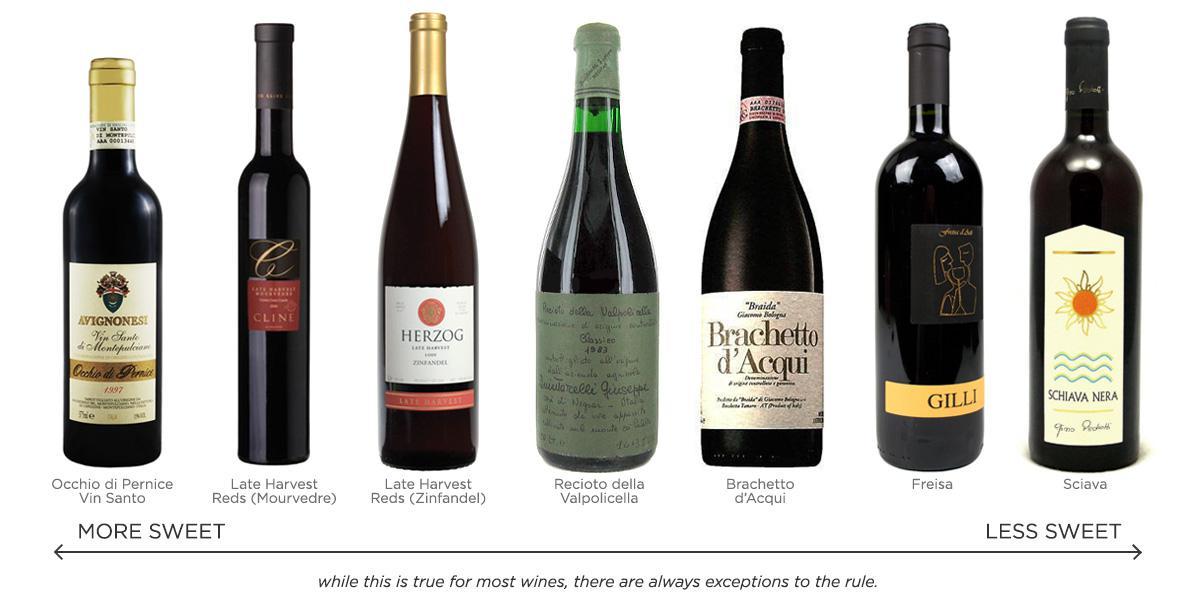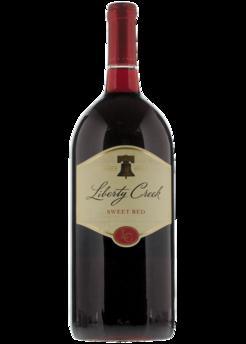The first image is the image on the left, the second image is the image on the right. Assess this claim about the two images: "A total of two wine bottles are depicted.". Correct or not? Answer yes or no. No. 